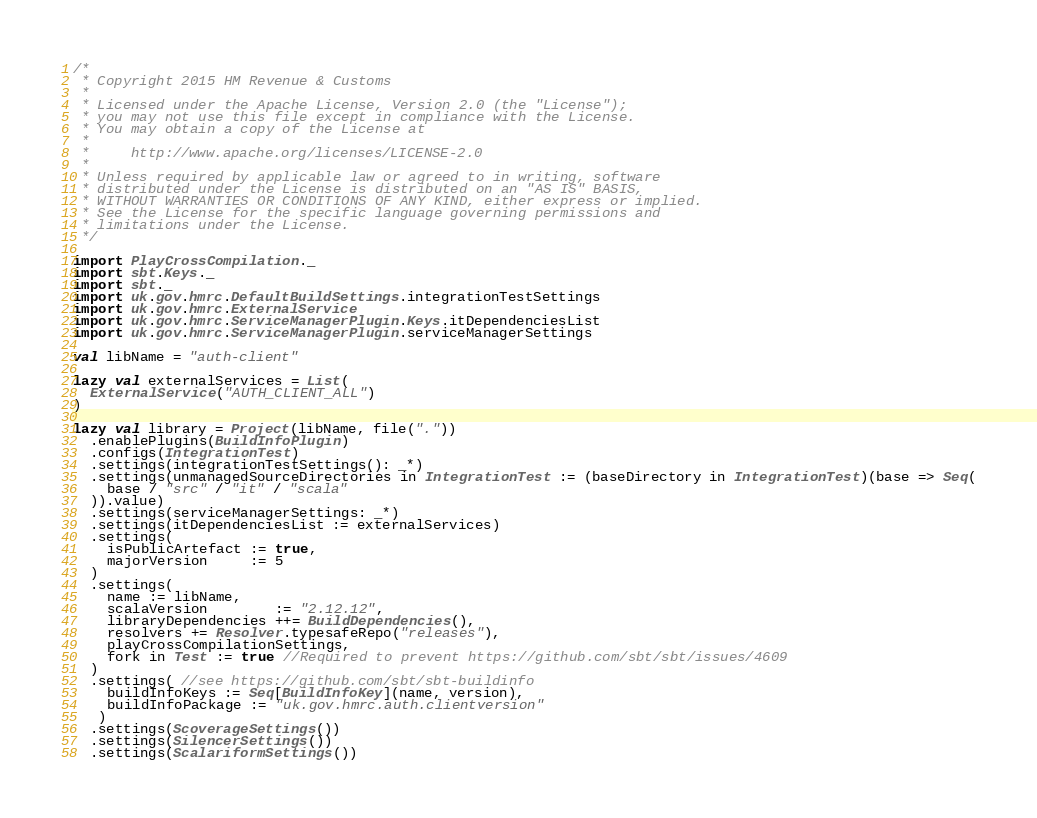<code> <loc_0><loc_0><loc_500><loc_500><_Scala_>/*
 * Copyright 2015 HM Revenue & Customs
 *
 * Licensed under the Apache License, Version 2.0 (the "License");
 * you may not use this file except in compliance with the License.
 * You may obtain a copy of the License at
 *
 *     http://www.apache.org/licenses/LICENSE-2.0
 *
 * Unless required by applicable law or agreed to in writing, software
 * distributed under the License is distributed on an "AS IS" BASIS,
 * WITHOUT WARRANTIES OR CONDITIONS OF ANY KIND, either express or implied.
 * See the License for the specific language governing permissions and
 * limitations under the License.
 */

import PlayCrossCompilation._
import sbt.Keys._
import sbt._
import uk.gov.hmrc.DefaultBuildSettings.integrationTestSettings
import uk.gov.hmrc.ExternalService
import uk.gov.hmrc.ServiceManagerPlugin.Keys.itDependenciesList
import uk.gov.hmrc.ServiceManagerPlugin.serviceManagerSettings

val libName = "auth-client"

lazy val externalServices = List(
  ExternalService("AUTH_CLIENT_ALL")
)

lazy val library = Project(libName, file("."))
  .enablePlugins(BuildInfoPlugin)
  .configs(IntegrationTest)
  .settings(integrationTestSettings(): _*)
  .settings(unmanagedSourceDirectories in IntegrationTest := (baseDirectory in IntegrationTest)(base => Seq(
    base / "src" / "it" / "scala"
  )).value)
  .settings(serviceManagerSettings: _*)
  .settings(itDependenciesList := externalServices)
  .settings(
    isPublicArtefact := true,
    majorVersion     := 5
  )
  .settings(
    name := libName,
    scalaVersion        := "2.12.12",
    libraryDependencies ++= BuildDependencies(),
    resolvers += Resolver.typesafeRepo("releases"),
    playCrossCompilationSettings,
    fork in Test := true //Required to prevent https://github.com/sbt/sbt/issues/4609
  )
  .settings( //see https://github.com/sbt/sbt-buildinfo
    buildInfoKeys := Seq[BuildInfoKey](name, version),
    buildInfoPackage := "uk.gov.hmrc.auth.clientversion"
   )
  .settings(ScoverageSettings())
  .settings(SilencerSettings())
  .settings(ScalariformSettings())
</code> 